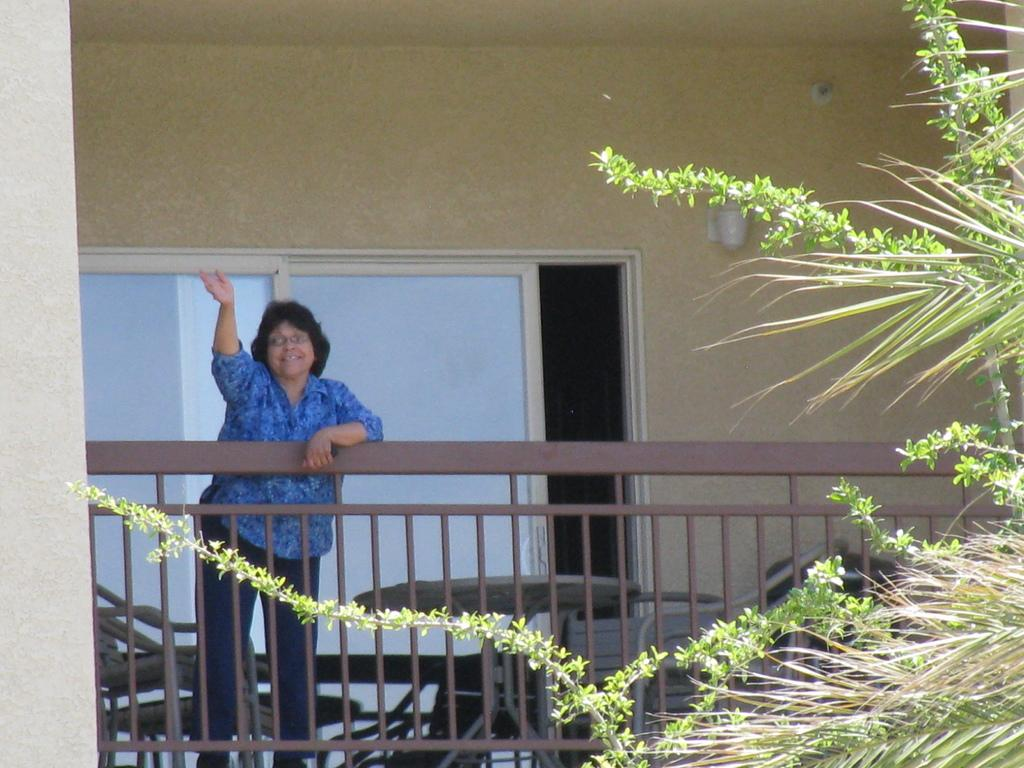Who is the main subject in the image? There is a woman in the image. What is in front of the woman? There is a fence in front of the woman. What is located beside the woman? There is a table beside the woman. What furniture is near the table? There are chairs near the table. What can be seen on the right side of the image? There is a tree on the right side of the image. What is the reaction of the nation to the silverware in the image? There is no mention of silverware in the image, and therefore no reaction from the nation can be observed. 